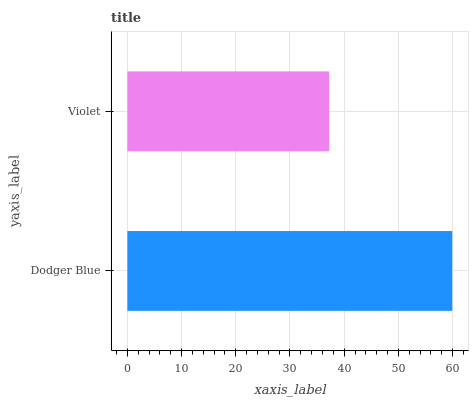Is Violet the minimum?
Answer yes or no. Yes. Is Dodger Blue the maximum?
Answer yes or no. Yes. Is Violet the maximum?
Answer yes or no. No. Is Dodger Blue greater than Violet?
Answer yes or no. Yes. Is Violet less than Dodger Blue?
Answer yes or no. Yes. Is Violet greater than Dodger Blue?
Answer yes or no. No. Is Dodger Blue less than Violet?
Answer yes or no. No. Is Dodger Blue the high median?
Answer yes or no. Yes. Is Violet the low median?
Answer yes or no. Yes. Is Violet the high median?
Answer yes or no. No. Is Dodger Blue the low median?
Answer yes or no. No. 